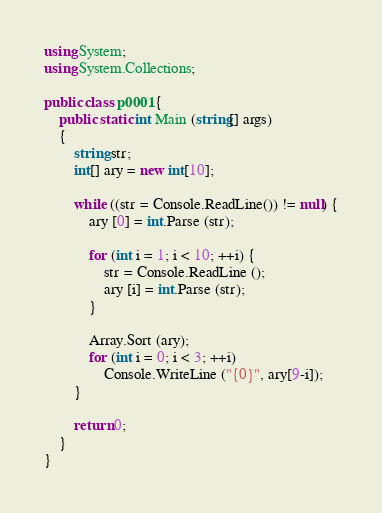Convert code to text. <code><loc_0><loc_0><loc_500><loc_500><_C#_>using System;
using System.Collections;

public class p0001{
	public static int Main (string[] args)
	{
		string str;
		int[] ary = new int[10];
		
		while ((str = Console.ReadLine()) != null) {
			ary [0] = int.Parse (str);
			
			for (int i = 1; i < 10; ++i) {
				str = Console.ReadLine ();
				ary [i] = int.Parse (str);
			}
			
			Array.Sort (ary);
			for (int i = 0; i < 3; ++i)
				Console.WriteLine ("{0}", ary[9-i]);
		}
		
		return 0;
	}
}</code> 